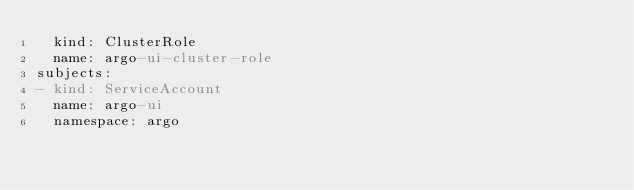Convert code to text. <code><loc_0><loc_0><loc_500><loc_500><_YAML_>  kind: ClusterRole
  name: argo-ui-cluster-role
subjects:
- kind: ServiceAccount
  name: argo-ui
  namespace: argo
</code> 